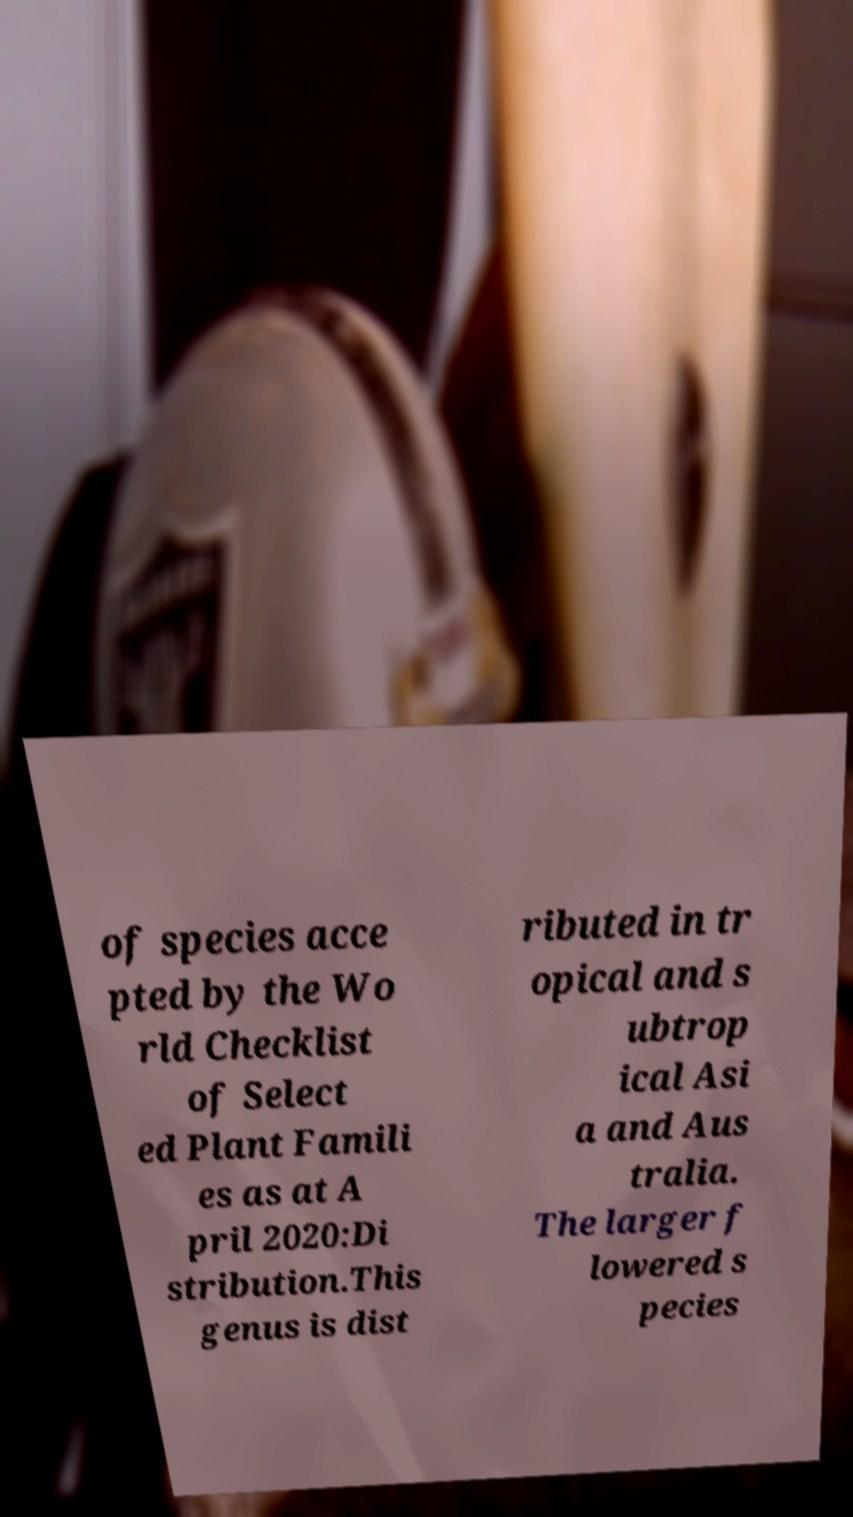Please identify and transcribe the text found in this image. of species acce pted by the Wo rld Checklist of Select ed Plant Famili es as at A pril 2020:Di stribution.This genus is dist ributed in tr opical and s ubtrop ical Asi a and Aus tralia. The larger f lowered s pecies 